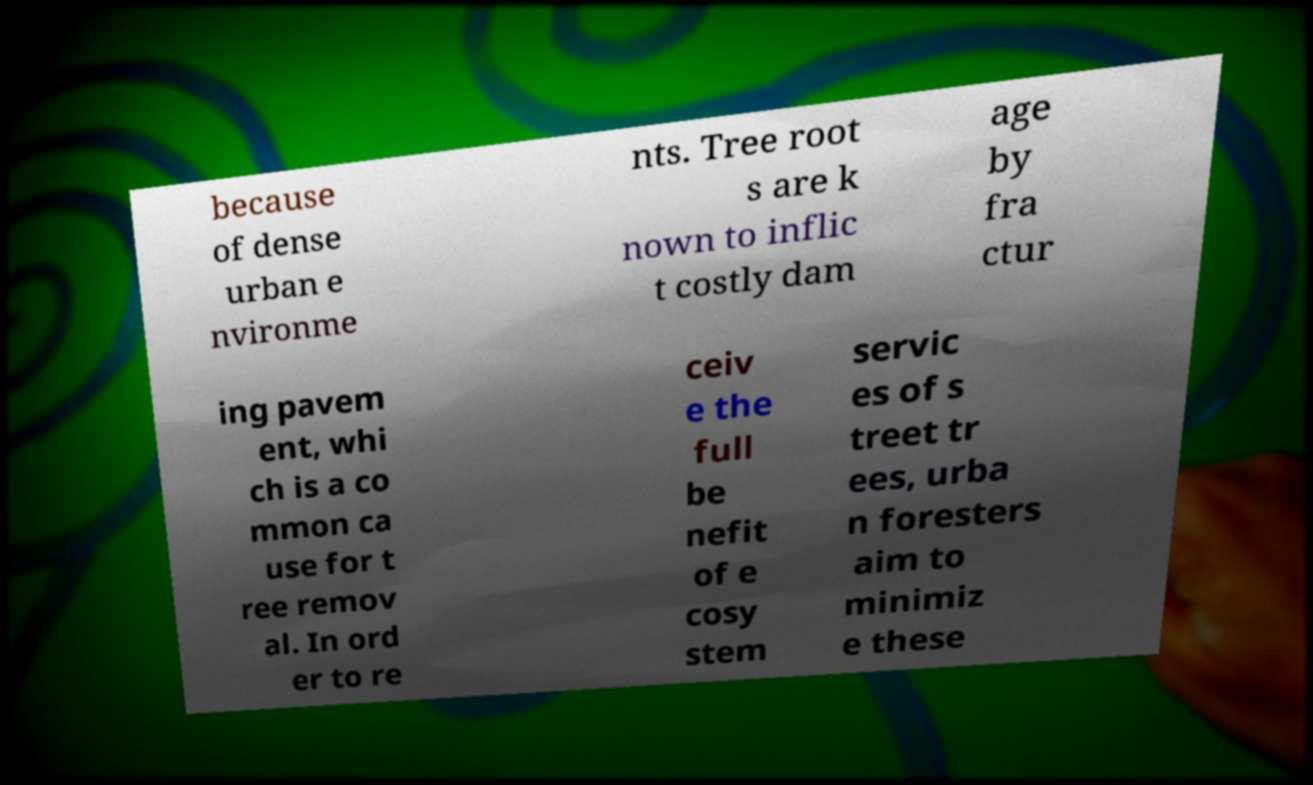Could you extract and type out the text from this image? because of dense urban e nvironme nts. Tree root s are k nown to inflic t costly dam age by fra ctur ing pavem ent, whi ch is a co mmon ca use for t ree remov al. In ord er to re ceiv e the full be nefit of e cosy stem servic es of s treet tr ees, urba n foresters aim to minimiz e these 